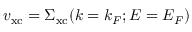<formula> <loc_0><loc_0><loc_500><loc_500>v _ { x c } = \Sigma _ { x c } ( k = k _ { F } ; E = E _ { F } )</formula> 